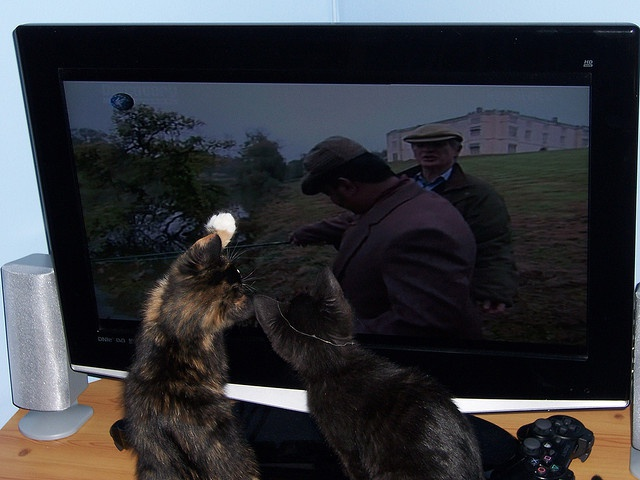Describe the objects in this image and their specific colors. I can see tv in black, lightblue, gray, and darkblue tones, people in black, navy, and lightblue tones, cat in lightblue, black, gray, and maroon tones, cat in lightblue, black, and gray tones, and people in lightblue, black, gray, and darkblue tones in this image. 